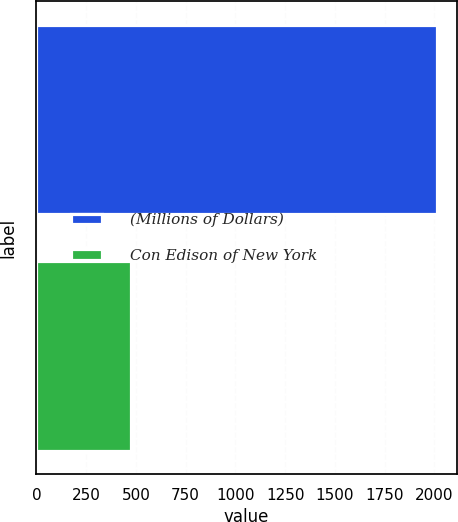Convert chart to OTSL. <chart><loc_0><loc_0><loc_500><loc_500><bar_chart><fcel>(Millions of Dollars)<fcel>Con Edison of New York<nl><fcel>2011<fcel>477<nl></chart> 